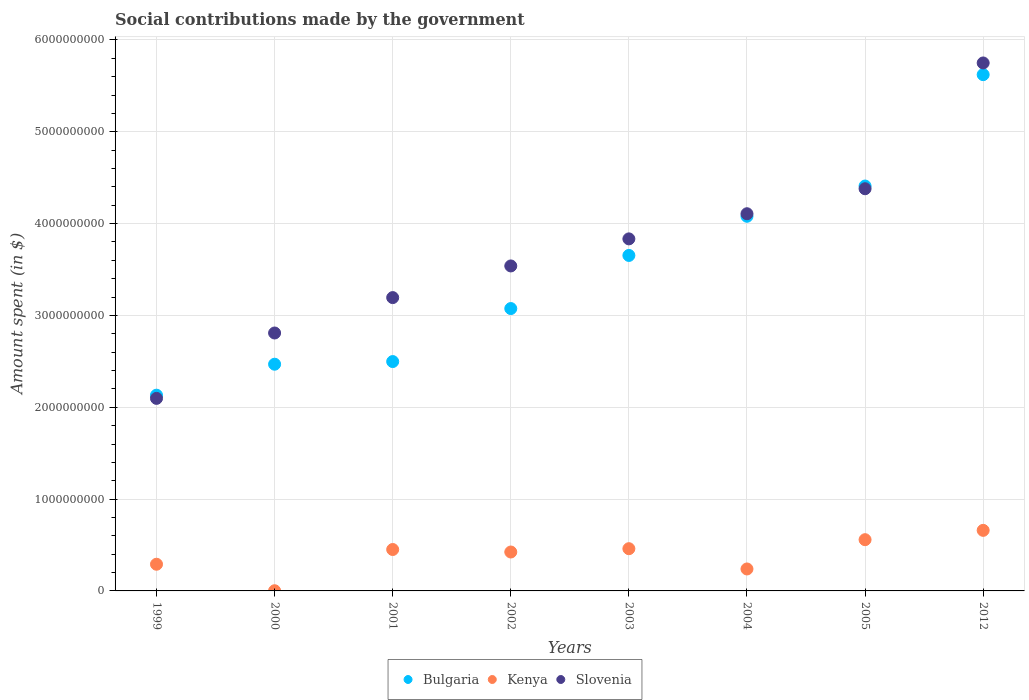How many different coloured dotlines are there?
Make the answer very short. 3. What is the amount spent on social contributions in Kenya in 2005?
Keep it short and to the point. 5.58e+08. Across all years, what is the maximum amount spent on social contributions in Kenya?
Offer a very short reply. 6.60e+08. Across all years, what is the minimum amount spent on social contributions in Bulgaria?
Ensure brevity in your answer.  2.13e+09. In which year was the amount spent on social contributions in Kenya maximum?
Provide a succinct answer. 2012. In which year was the amount spent on social contributions in Bulgaria minimum?
Keep it short and to the point. 1999. What is the total amount spent on social contributions in Kenya in the graph?
Your answer should be compact. 3.08e+09. What is the difference between the amount spent on social contributions in Slovenia in 2001 and that in 2012?
Offer a terse response. -2.56e+09. What is the difference between the amount spent on social contributions in Slovenia in 2000 and the amount spent on social contributions in Kenya in 2005?
Your answer should be very brief. 2.25e+09. What is the average amount spent on social contributions in Bulgaria per year?
Provide a short and direct response. 3.49e+09. In the year 2004, what is the difference between the amount spent on social contributions in Bulgaria and amount spent on social contributions in Slovenia?
Make the answer very short. -2.76e+07. What is the ratio of the amount spent on social contributions in Bulgaria in 2000 to that in 2005?
Your answer should be compact. 0.56. Is the amount spent on social contributions in Kenya in 1999 less than that in 2005?
Your answer should be very brief. Yes. What is the difference between the highest and the second highest amount spent on social contributions in Kenya?
Offer a terse response. 1.02e+08. What is the difference between the highest and the lowest amount spent on social contributions in Kenya?
Give a very brief answer. 6.58e+08. Is it the case that in every year, the sum of the amount spent on social contributions in Bulgaria and amount spent on social contributions in Slovenia  is greater than the amount spent on social contributions in Kenya?
Make the answer very short. Yes. Is the amount spent on social contributions in Bulgaria strictly greater than the amount spent on social contributions in Slovenia over the years?
Provide a succinct answer. No. How many dotlines are there?
Keep it short and to the point. 3. How many years are there in the graph?
Keep it short and to the point. 8. Does the graph contain grids?
Provide a succinct answer. Yes. Where does the legend appear in the graph?
Offer a terse response. Bottom center. What is the title of the graph?
Your answer should be very brief. Social contributions made by the government. Does "Middle income" appear as one of the legend labels in the graph?
Provide a short and direct response. No. What is the label or title of the X-axis?
Give a very brief answer. Years. What is the label or title of the Y-axis?
Offer a very short reply. Amount spent (in $). What is the Amount spent (in $) in Bulgaria in 1999?
Give a very brief answer. 2.13e+09. What is the Amount spent (in $) of Kenya in 1999?
Offer a very short reply. 2.91e+08. What is the Amount spent (in $) in Slovenia in 1999?
Your answer should be compact. 2.10e+09. What is the Amount spent (in $) of Bulgaria in 2000?
Your answer should be very brief. 2.47e+09. What is the Amount spent (in $) in Kenya in 2000?
Keep it short and to the point. 2.00e+06. What is the Amount spent (in $) in Slovenia in 2000?
Your answer should be very brief. 2.81e+09. What is the Amount spent (in $) in Bulgaria in 2001?
Ensure brevity in your answer.  2.50e+09. What is the Amount spent (in $) in Kenya in 2001?
Make the answer very short. 4.51e+08. What is the Amount spent (in $) in Slovenia in 2001?
Your response must be concise. 3.19e+09. What is the Amount spent (in $) of Bulgaria in 2002?
Keep it short and to the point. 3.08e+09. What is the Amount spent (in $) in Kenya in 2002?
Make the answer very short. 4.24e+08. What is the Amount spent (in $) in Slovenia in 2002?
Your answer should be very brief. 3.54e+09. What is the Amount spent (in $) in Bulgaria in 2003?
Your answer should be compact. 3.65e+09. What is the Amount spent (in $) of Kenya in 2003?
Offer a very short reply. 4.60e+08. What is the Amount spent (in $) in Slovenia in 2003?
Give a very brief answer. 3.83e+09. What is the Amount spent (in $) in Bulgaria in 2004?
Your answer should be very brief. 4.08e+09. What is the Amount spent (in $) of Kenya in 2004?
Your response must be concise. 2.39e+08. What is the Amount spent (in $) in Slovenia in 2004?
Your answer should be very brief. 4.11e+09. What is the Amount spent (in $) of Bulgaria in 2005?
Your answer should be compact. 4.41e+09. What is the Amount spent (in $) of Kenya in 2005?
Your answer should be compact. 5.58e+08. What is the Amount spent (in $) of Slovenia in 2005?
Your answer should be very brief. 4.38e+09. What is the Amount spent (in $) of Bulgaria in 2012?
Offer a terse response. 5.62e+09. What is the Amount spent (in $) in Kenya in 2012?
Keep it short and to the point. 6.60e+08. What is the Amount spent (in $) in Slovenia in 2012?
Your response must be concise. 5.75e+09. Across all years, what is the maximum Amount spent (in $) of Bulgaria?
Offer a terse response. 5.62e+09. Across all years, what is the maximum Amount spent (in $) in Kenya?
Provide a succinct answer. 6.60e+08. Across all years, what is the maximum Amount spent (in $) in Slovenia?
Keep it short and to the point. 5.75e+09. Across all years, what is the minimum Amount spent (in $) of Bulgaria?
Your answer should be compact. 2.13e+09. Across all years, what is the minimum Amount spent (in $) of Slovenia?
Provide a succinct answer. 2.10e+09. What is the total Amount spent (in $) in Bulgaria in the graph?
Offer a terse response. 2.79e+1. What is the total Amount spent (in $) in Kenya in the graph?
Ensure brevity in your answer.  3.08e+09. What is the total Amount spent (in $) of Slovenia in the graph?
Provide a succinct answer. 2.97e+1. What is the difference between the Amount spent (in $) in Bulgaria in 1999 and that in 2000?
Keep it short and to the point. -3.37e+08. What is the difference between the Amount spent (in $) in Kenya in 1999 and that in 2000?
Your response must be concise. 2.89e+08. What is the difference between the Amount spent (in $) of Slovenia in 1999 and that in 2000?
Your response must be concise. -7.12e+08. What is the difference between the Amount spent (in $) of Bulgaria in 1999 and that in 2001?
Your response must be concise. -3.66e+08. What is the difference between the Amount spent (in $) of Kenya in 1999 and that in 2001?
Provide a succinct answer. -1.60e+08. What is the difference between the Amount spent (in $) of Slovenia in 1999 and that in 2001?
Your answer should be compact. -1.10e+09. What is the difference between the Amount spent (in $) in Bulgaria in 1999 and that in 2002?
Provide a succinct answer. -9.43e+08. What is the difference between the Amount spent (in $) of Kenya in 1999 and that in 2002?
Ensure brevity in your answer.  -1.33e+08. What is the difference between the Amount spent (in $) in Slovenia in 1999 and that in 2002?
Offer a very short reply. -1.44e+09. What is the difference between the Amount spent (in $) in Bulgaria in 1999 and that in 2003?
Offer a terse response. -1.52e+09. What is the difference between the Amount spent (in $) of Kenya in 1999 and that in 2003?
Offer a very short reply. -1.69e+08. What is the difference between the Amount spent (in $) in Slovenia in 1999 and that in 2003?
Your answer should be very brief. -1.74e+09. What is the difference between the Amount spent (in $) of Bulgaria in 1999 and that in 2004?
Provide a short and direct response. -1.95e+09. What is the difference between the Amount spent (in $) in Kenya in 1999 and that in 2004?
Keep it short and to the point. 5.15e+07. What is the difference between the Amount spent (in $) in Slovenia in 1999 and that in 2004?
Offer a very short reply. -2.01e+09. What is the difference between the Amount spent (in $) in Bulgaria in 1999 and that in 2005?
Keep it short and to the point. -2.28e+09. What is the difference between the Amount spent (in $) of Kenya in 1999 and that in 2005?
Make the answer very short. -2.67e+08. What is the difference between the Amount spent (in $) in Slovenia in 1999 and that in 2005?
Keep it short and to the point. -2.28e+09. What is the difference between the Amount spent (in $) of Bulgaria in 1999 and that in 2012?
Offer a very short reply. -3.49e+09. What is the difference between the Amount spent (in $) of Kenya in 1999 and that in 2012?
Provide a short and direct response. -3.69e+08. What is the difference between the Amount spent (in $) of Slovenia in 1999 and that in 2012?
Provide a short and direct response. -3.65e+09. What is the difference between the Amount spent (in $) of Bulgaria in 2000 and that in 2001?
Your response must be concise. -2.89e+07. What is the difference between the Amount spent (in $) in Kenya in 2000 and that in 2001?
Keep it short and to the point. -4.49e+08. What is the difference between the Amount spent (in $) of Slovenia in 2000 and that in 2001?
Your answer should be very brief. -3.85e+08. What is the difference between the Amount spent (in $) of Bulgaria in 2000 and that in 2002?
Make the answer very short. -6.06e+08. What is the difference between the Amount spent (in $) of Kenya in 2000 and that in 2002?
Your response must be concise. -4.22e+08. What is the difference between the Amount spent (in $) of Slovenia in 2000 and that in 2002?
Offer a terse response. -7.30e+08. What is the difference between the Amount spent (in $) in Bulgaria in 2000 and that in 2003?
Your answer should be compact. -1.18e+09. What is the difference between the Amount spent (in $) in Kenya in 2000 and that in 2003?
Provide a succinct answer. -4.58e+08. What is the difference between the Amount spent (in $) in Slovenia in 2000 and that in 2003?
Give a very brief answer. -1.02e+09. What is the difference between the Amount spent (in $) of Bulgaria in 2000 and that in 2004?
Your answer should be compact. -1.61e+09. What is the difference between the Amount spent (in $) of Kenya in 2000 and that in 2004?
Give a very brief answer. -2.37e+08. What is the difference between the Amount spent (in $) of Slovenia in 2000 and that in 2004?
Ensure brevity in your answer.  -1.30e+09. What is the difference between the Amount spent (in $) in Bulgaria in 2000 and that in 2005?
Offer a very short reply. -1.94e+09. What is the difference between the Amount spent (in $) in Kenya in 2000 and that in 2005?
Your answer should be very brief. -5.56e+08. What is the difference between the Amount spent (in $) in Slovenia in 2000 and that in 2005?
Keep it short and to the point. -1.57e+09. What is the difference between the Amount spent (in $) in Bulgaria in 2000 and that in 2012?
Keep it short and to the point. -3.15e+09. What is the difference between the Amount spent (in $) of Kenya in 2000 and that in 2012?
Your answer should be compact. -6.58e+08. What is the difference between the Amount spent (in $) of Slovenia in 2000 and that in 2012?
Ensure brevity in your answer.  -2.94e+09. What is the difference between the Amount spent (in $) in Bulgaria in 2001 and that in 2002?
Provide a succinct answer. -5.77e+08. What is the difference between the Amount spent (in $) of Kenya in 2001 and that in 2002?
Your response must be concise. 2.73e+07. What is the difference between the Amount spent (in $) in Slovenia in 2001 and that in 2002?
Provide a succinct answer. -3.45e+08. What is the difference between the Amount spent (in $) in Bulgaria in 2001 and that in 2003?
Your response must be concise. -1.16e+09. What is the difference between the Amount spent (in $) in Kenya in 2001 and that in 2003?
Offer a very short reply. -8.90e+06. What is the difference between the Amount spent (in $) of Slovenia in 2001 and that in 2003?
Your response must be concise. -6.39e+08. What is the difference between the Amount spent (in $) of Bulgaria in 2001 and that in 2004?
Provide a succinct answer. -1.58e+09. What is the difference between the Amount spent (in $) of Kenya in 2001 and that in 2004?
Ensure brevity in your answer.  2.12e+08. What is the difference between the Amount spent (in $) in Slovenia in 2001 and that in 2004?
Your answer should be very brief. -9.13e+08. What is the difference between the Amount spent (in $) of Bulgaria in 2001 and that in 2005?
Provide a short and direct response. -1.91e+09. What is the difference between the Amount spent (in $) of Kenya in 2001 and that in 2005?
Keep it short and to the point. -1.07e+08. What is the difference between the Amount spent (in $) in Slovenia in 2001 and that in 2005?
Provide a succinct answer. -1.19e+09. What is the difference between the Amount spent (in $) in Bulgaria in 2001 and that in 2012?
Provide a short and direct response. -3.12e+09. What is the difference between the Amount spent (in $) of Kenya in 2001 and that in 2012?
Offer a terse response. -2.09e+08. What is the difference between the Amount spent (in $) of Slovenia in 2001 and that in 2012?
Offer a terse response. -2.56e+09. What is the difference between the Amount spent (in $) of Bulgaria in 2002 and that in 2003?
Give a very brief answer. -5.78e+08. What is the difference between the Amount spent (in $) in Kenya in 2002 and that in 2003?
Ensure brevity in your answer.  -3.62e+07. What is the difference between the Amount spent (in $) in Slovenia in 2002 and that in 2003?
Provide a short and direct response. -2.95e+08. What is the difference between the Amount spent (in $) in Bulgaria in 2002 and that in 2004?
Offer a very short reply. -1.01e+09. What is the difference between the Amount spent (in $) in Kenya in 2002 and that in 2004?
Your answer should be very brief. 1.85e+08. What is the difference between the Amount spent (in $) of Slovenia in 2002 and that in 2004?
Provide a short and direct response. -5.69e+08. What is the difference between the Amount spent (in $) of Bulgaria in 2002 and that in 2005?
Your response must be concise. -1.33e+09. What is the difference between the Amount spent (in $) of Kenya in 2002 and that in 2005?
Provide a succinct answer. -1.34e+08. What is the difference between the Amount spent (in $) of Slovenia in 2002 and that in 2005?
Ensure brevity in your answer.  -8.41e+08. What is the difference between the Amount spent (in $) in Bulgaria in 2002 and that in 2012?
Provide a succinct answer. -2.55e+09. What is the difference between the Amount spent (in $) of Kenya in 2002 and that in 2012?
Provide a succinct answer. -2.36e+08. What is the difference between the Amount spent (in $) in Slovenia in 2002 and that in 2012?
Offer a very short reply. -2.21e+09. What is the difference between the Amount spent (in $) in Bulgaria in 2003 and that in 2004?
Keep it short and to the point. -4.27e+08. What is the difference between the Amount spent (in $) in Kenya in 2003 and that in 2004?
Your answer should be compact. 2.21e+08. What is the difference between the Amount spent (in $) of Slovenia in 2003 and that in 2004?
Keep it short and to the point. -2.74e+08. What is the difference between the Amount spent (in $) in Bulgaria in 2003 and that in 2005?
Offer a terse response. -7.56e+08. What is the difference between the Amount spent (in $) of Kenya in 2003 and that in 2005?
Keep it short and to the point. -9.81e+07. What is the difference between the Amount spent (in $) in Slovenia in 2003 and that in 2005?
Keep it short and to the point. -5.46e+08. What is the difference between the Amount spent (in $) of Bulgaria in 2003 and that in 2012?
Ensure brevity in your answer.  -1.97e+09. What is the difference between the Amount spent (in $) of Kenya in 2003 and that in 2012?
Your answer should be very brief. -2.00e+08. What is the difference between the Amount spent (in $) of Slovenia in 2003 and that in 2012?
Offer a terse response. -1.92e+09. What is the difference between the Amount spent (in $) of Bulgaria in 2004 and that in 2005?
Give a very brief answer. -3.29e+08. What is the difference between the Amount spent (in $) in Kenya in 2004 and that in 2005?
Offer a terse response. -3.19e+08. What is the difference between the Amount spent (in $) of Slovenia in 2004 and that in 2005?
Ensure brevity in your answer.  -2.72e+08. What is the difference between the Amount spent (in $) of Bulgaria in 2004 and that in 2012?
Your answer should be very brief. -1.54e+09. What is the difference between the Amount spent (in $) in Kenya in 2004 and that in 2012?
Make the answer very short. -4.20e+08. What is the difference between the Amount spent (in $) in Slovenia in 2004 and that in 2012?
Ensure brevity in your answer.  -1.64e+09. What is the difference between the Amount spent (in $) of Bulgaria in 2005 and that in 2012?
Keep it short and to the point. -1.21e+09. What is the difference between the Amount spent (in $) of Kenya in 2005 and that in 2012?
Your answer should be compact. -1.02e+08. What is the difference between the Amount spent (in $) of Slovenia in 2005 and that in 2012?
Make the answer very short. -1.37e+09. What is the difference between the Amount spent (in $) of Bulgaria in 1999 and the Amount spent (in $) of Kenya in 2000?
Give a very brief answer. 2.13e+09. What is the difference between the Amount spent (in $) of Bulgaria in 1999 and the Amount spent (in $) of Slovenia in 2000?
Make the answer very short. -6.77e+08. What is the difference between the Amount spent (in $) in Kenya in 1999 and the Amount spent (in $) in Slovenia in 2000?
Keep it short and to the point. -2.52e+09. What is the difference between the Amount spent (in $) in Bulgaria in 1999 and the Amount spent (in $) in Kenya in 2001?
Offer a terse response. 1.68e+09. What is the difference between the Amount spent (in $) of Bulgaria in 1999 and the Amount spent (in $) of Slovenia in 2001?
Ensure brevity in your answer.  -1.06e+09. What is the difference between the Amount spent (in $) in Kenya in 1999 and the Amount spent (in $) in Slovenia in 2001?
Give a very brief answer. -2.90e+09. What is the difference between the Amount spent (in $) in Bulgaria in 1999 and the Amount spent (in $) in Kenya in 2002?
Offer a very short reply. 1.71e+09. What is the difference between the Amount spent (in $) in Bulgaria in 1999 and the Amount spent (in $) in Slovenia in 2002?
Offer a terse response. -1.41e+09. What is the difference between the Amount spent (in $) of Kenya in 1999 and the Amount spent (in $) of Slovenia in 2002?
Keep it short and to the point. -3.25e+09. What is the difference between the Amount spent (in $) of Bulgaria in 1999 and the Amount spent (in $) of Kenya in 2003?
Provide a short and direct response. 1.67e+09. What is the difference between the Amount spent (in $) in Bulgaria in 1999 and the Amount spent (in $) in Slovenia in 2003?
Ensure brevity in your answer.  -1.70e+09. What is the difference between the Amount spent (in $) in Kenya in 1999 and the Amount spent (in $) in Slovenia in 2003?
Your response must be concise. -3.54e+09. What is the difference between the Amount spent (in $) in Bulgaria in 1999 and the Amount spent (in $) in Kenya in 2004?
Make the answer very short. 1.89e+09. What is the difference between the Amount spent (in $) of Bulgaria in 1999 and the Amount spent (in $) of Slovenia in 2004?
Make the answer very short. -1.98e+09. What is the difference between the Amount spent (in $) of Kenya in 1999 and the Amount spent (in $) of Slovenia in 2004?
Keep it short and to the point. -3.82e+09. What is the difference between the Amount spent (in $) of Bulgaria in 1999 and the Amount spent (in $) of Kenya in 2005?
Your answer should be compact. 1.57e+09. What is the difference between the Amount spent (in $) in Bulgaria in 1999 and the Amount spent (in $) in Slovenia in 2005?
Your answer should be compact. -2.25e+09. What is the difference between the Amount spent (in $) of Kenya in 1999 and the Amount spent (in $) of Slovenia in 2005?
Keep it short and to the point. -4.09e+09. What is the difference between the Amount spent (in $) of Bulgaria in 1999 and the Amount spent (in $) of Kenya in 2012?
Offer a very short reply. 1.47e+09. What is the difference between the Amount spent (in $) of Bulgaria in 1999 and the Amount spent (in $) of Slovenia in 2012?
Keep it short and to the point. -3.62e+09. What is the difference between the Amount spent (in $) of Kenya in 1999 and the Amount spent (in $) of Slovenia in 2012?
Your answer should be very brief. -5.46e+09. What is the difference between the Amount spent (in $) of Bulgaria in 2000 and the Amount spent (in $) of Kenya in 2001?
Provide a short and direct response. 2.02e+09. What is the difference between the Amount spent (in $) in Bulgaria in 2000 and the Amount spent (in $) in Slovenia in 2001?
Offer a very short reply. -7.25e+08. What is the difference between the Amount spent (in $) of Kenya in 2000 and the Amount spent (in $) of Slovenia in 2001?
Make the answer very short. -3.19e+09. What is the difference between the Amount spent (in $) of Bulgaria in 2000 and the Amount spent (in $) of Kenya in 2002?
Give a very brief answer. 2.05e+09. What is the difference between the Amount spent (in $) of Bulgaria in 2000 and the Amount spent (in $) of Slovenia in 2002?
Ensure brevity in your answer.  -1.07e+09. What is the difference between the Amount spent (in $) of Kenya in 2000 and the Amount spent (in $) of Slovenia in 2002?
Keep it short and to the point. -3.54e+09. What is the difference between the Amount spent (in $) of Bulgaria in 2000 and the Amount spent (in $) of Kenya in 2003?
Provide a short and direct response. 2.01e+09. What is the difference between the Amount spent (in $) in Bulgaria in 2000 and the Amount spent (in $) in Slovenia in 2003?
Provide a succinct answer. -1.36e+09. What is the difference between the Amount spent (in $) in Kenya in 2000 and the Amount spent (in $) in Slovenia in 2003?
Your answer should be very brief. -3.83e+09. What is the difference between the Amount spent (in $) of Bulgaria in 2000 and the Amount spent (in $) of Kenya in 2004?
Offer a very short reply. 2.23e+09. What is the difference between the Amount spent (in $) of Bulgaria in 2000 and the Amount spent (in $) of Slovenia in 2004?
Give a very brief answer. -1.64e+09. What is the difference between the Amount spent (in $) in Kenya in 2000 and the Amount spent (in $) in Slovenia in 2004?
Your answer should be very brief. -4.11e+09. What is the difference between the Amount spent (in $) of Bulgaria in 2000 and the Amount spent (in $) of Kenya in 2005?
Ensure brevity in your answer.  1.91e+09. What is the difference between the Amount spent (in $) in Bulgaria in 2000 and the Amount spent (in $) in Slovenia in 2005?
Provide a short and direct response. -1.91e+09. What is the difference between the Amount spent (in $) of Kenya in 2000 and the Amount spent (in $) of Slovenia in 2005?
Keep it short and to the point. -4.38e+09. What is the difference between the Amount spent (in $) in Bulgaria in 2000 and the Amount spent (in $) in Kenya in 2012?
Give a very brief answer. 1.81e+09. What is the difference between the Amount spent (in $) in Bulgaria in 2000 and the Amount spent (in $) in Slovenia in 2012?
Your response must be concise. -3.28e+09. What is the difference between the Amount spent (in $) in Kenya in 2000 and the Amount spent (in $) in Slovenia in 2012?
Make the answer very short. -5.75e+09. What is the difference between the Amount spent (in $) in Bulgaria in 2001 and the Amount spent (in $) in Kenya in 2002?
Keep it short and to the point. 2.07e+09. What is the difference between the Amount spent (in $) in Bulgaria in 2001 and the Amount spent (in $) in Slovenia in 2002?
Provide a short and direct response. -1.04e+09. What is the difference between the Amount spent (in $) of Kenya in 2001 and the Amount spent (in $) of Slovenia in 2002?
Provide a succinct answer. -3.09e+09. What is the difference between the Amount spent (in $) of Bulgaria in 2001 and the Amount spent (in $) of Kenya in 2003?
Your answer should be compact. 2.04e+09. What is the difference between the Amount spent (in $) of Bulgaria in 2001 and the Amount spent (in $) of Slovenia in 2003?
Keep it short and to the point. -1.34e+09. What is the difference between the Amount spent (in $) of Kenya in 2001 and the Amount spent (in $) of Slovenia in 2003?
Your response must be concise. -3.38e+09. What is the difference between the Amount spent (in $) of Bulgaria in 2001 and the Amount spent (in $) of Kenya in 2004?
Ensure brevity in your answer.  2.26e+09. What is the difference between the Amount spent (in $) in Bulgaria in 2001 and the Amount spent (in $) in Slovenia in 2004?
Give a very brief answer. -1.61e+09. What is the difference between the Amount spent (in $) in Kenya in 2001 and the Amount spent (in $) in Slovenia in 2004?
Ensure brevity in your answer.  -3.66e+09. What is the difference between the Amount spent (in $) in Bulgaria in 2001 and the Amount spent (in $) in Kenya in 2005?
Your response must be concise. 1.94e+09. What is the difference between the Amount spent (in $) of Bulgaria in 2001 and the Amount spent (in $) of Slovenia in 2005?
Make the answer very short. -1.88e+09. What is the difference between the Amount spent (in $) of Kenya in 2001 and the Amount spent (in $) of Slovenia in 2005?
Offer a terse response. -3.93e+09. What is the difference between the Amount spent (in $) in Bulgaria in 2001 and the Amount spent (in $) in Kenya in 2012?
Your answer should be compact. 1.84e+09. What is the difference between the Amount spent (in $) of Bulgaria in 2001 and the Amount spent (in $) of Slovenia in 2012?
Provide a short and direct response. -3.25e+09. What is the difference between the Amount spent (in $) of Kenya in 2001 and the Amount spent (in $) of Slovenia in 2012?
Give a very brief answer. -5.30e+09. What is the difference between the Amount spent (in $) in Bulgaria in 2002 and the Amount spent (in $) in Kenya in 2003?
Offer a very short reply. 2.62e+09. What is the difference between the Amount spent (in $) in Bulgaria in 2002 and the Amount spent (in $) in Slovenia in 2003?
Ensure brevity in your answer.  -7.59e+08. What is the difference between the Amount spent (in $) in Kenya in 2002 and the Amount spent (in $) in Slovenia in 2003?
Your answer should be very brief. -3.41e+09. What is the difference between the Amount spent (in $) in Bulgaria in 2002 and the Amount spent (in $) in Kenya in 2004?
Provide a succinct answer. 2.84e+09. What is the difference between the Amount spent (in $) of Bulgaria in 2002 and the Amount spent (in $) of Slovenia in 2004?
Your answer should be very brief. -1.03e+09. What is the difference between the Amount spent (in $) in Kenya in 2002 and the Amount spent (in $) in Slovenia in 2004?
Offer a terse response. -3.68e+09. What is the difference between the Amount spent (in $) of Bulgaria in 2002 and the Amount spent (in $) of Kenya in 2005?
Offer a terse response. 2.52e+09. What is the difference between the Amount spent (in $) of Bulgaria in 2002 and the Amount spent (in $) of Slovenia in 2005?
Provide a succinct answer. -1.30e+09. What is the difference between the Amount spent (in $) of Kenya in 2002 and the Amount spent (in $) of Slovenia in 2005?
Provide a succinct answer. -3.96e+09. What is the difference between the Amount spent (in $) of Bulgaria in 2002 and the Amount spent (in $) of Kenya in 2012?
Provide a short and direct response. 2.42e+09. What is the difference between the Amount spent (in $) in Bulgaria in 2002 and the Amount spent (in $) in Slovenia in 2012?
Give a very brief answer. -2.67e+09. What is the difference between the Amount spent (in $) in Kenya in 2002 and the Amount spent (in $) in Slovenia in 2012?
Your response must be concise. -5.33e+09. What is the difference between the Amount spent (in $) in Bulgaria in 2003 and the Amount spent (in $) in Kenya in 2004?
Your answer should be very brief. 3.41e+09. What is the difference between the Amount spent (in $) in Bulgaria in 2003 and the Amount spent (in $) in Slovenia in 2004?
Provide a succinct answer. -4.54e+08. What is the difference between the Amount spent (in $) of Kenya in 2003 and the Amount spent (in $) of Slovenia in 2004?
Provide a succinct answer. -3.65e+09. What is the difference between the Amount spent (in $) of Bulgaria in 2003 and the Amount spent (in $) of Kenya in 2005?
Provide a succinct answer. 3.10e+09. What is the difference between the Amount spent (in $) of Bulgaria in 2003 and the Amount spent (in $) of Slovenia in 2005?
Your answer should be very brief. -7.26e+08. What is the difference between the Amount spent (in $) of Kenya in 2003 and the Amount spent (in $) of Slovenia in 2005?
Make the answer very short. -3.92e+09. What is the difference between the Amount spent (in $) of Bulgaria in 2003 and the Amount spent (in $) of Kenya in 2012?
Your answer should be very brief. 2.99e+09. What is the difference between the Amount spent (in $) in Bulgaria in 2003 and the Amount spent (in $) in Slovenia in 2012?
Give a very brief answer. -2.10e+09. What is the difference between the Amount spent (in $) in Kenya in 2003 and the Amount spent (in $) in Slovenia in 2012?
Keep it short and to the point. -5.29e+09. What is the difference between the Amount spent (in $) in Bulgaria in 2004 and the Amount spent (in $) in Kenya in 2005?
Offer a terse response. 3.52e+09. What is the difference between the Amount spent (in $) of Bulgaria in 2004 and the Amount spent (in $) of Slovenia in 2005?
Ensure brevity in your answer.  -3.00e+08. What is the difference between the Amount spent (in $) in Kenya in 2004 and the Amount spent (in $) in Slovenia in 2005?
Make the answer very short. -4.14e+09. What is the difference between the Amount spent (in $) of Bulgaria in 2004 and the Amount spent (in $) of Kenya in 2012?
Offer a very short reply. 3.42e+09. What is the difference between the Amount spent (in $) of Bulgaria in 2004 and the Amount spent (in $) of Slovenia in 2012?
Provide a short and direct response. -1.67e+09. What is the difference between the Amount spent (in $) of Kenya in 2004 and the Amount spent (in $) of Slovenia in 2012?
Your answer should be very brief. -5.51e+09. What is the difference between the Amount spent (in $) of Bulgaria in 2005 and the Amount spent (in $) of Kenya in 2012?
Give a very brief answer. 3.75e+09. What is the difference between the Amount spent (in $) in Bulgaria in 2005 and the Amount spent (in $) in Slovenia in 2012?
Your answer should be very brief. -1.34e+09. What is the difference between the Amount spent (in $) of Kenya in 2005 and the Amount spent (in $) of Slovenia in 2012?
Ensure brevity in your answer.  -5.19e+09. What is the average Amount spent (in $) in Bulgaria per year?
Offer a terse response. 3.49e+09. What is the average Amount spent (in $) of Kenya per year?
Provide a short and direct response. 3.85e+08. What is the average Amount spent (in $) of Slovenia per year?
Give a very brief answer. 3.71e+09. In the year 1999, what is the difference between the Amount spent (in $) of Bulgaria and Amount spent (in $) of Kenya?
Offer a very short reply. 1.84e+09. In the year 1999, what is the difference between the Amount spent (in $) in Bulgaria and Amount spent (in $) in Slovenia?
Provide a succinct answer. 3.48e+07. In the year 1999, what is the difference between the Amount spent (in $) of Kenya and Amount spent (in $) of Slovenia?
Your answer should be very brief. -1.81e+09. In the year 2000, what is the difference between the Amount spent (in $) in Bulgaria and Amount spent (in $) in Kenya?
Ensure brevity in your answer.  2.47e+09. In the year 2000, what is the difference between the Amount spent (in $) in Bulgaria and Amount spent (in $) in Slovenia?
Your response must be concise. -3.40e+08. In the year 2000, what is the difference between the Amount spent (in $) in Kenya and Amount spent (in $) in Slovenia?
Give a very brief answer. -2.81e+09. In the year 2001, what is the difference between the Amount spent (in $) of Bulgaria and Amount spent (in $) of Kenya?
Make the answer very short. 2.05e+09. In the year 2001, what is the difference between the Amount spent (in $) in Bulgaria and Amount spent (in $) in Slovenia?
Offer a terse response. -6.97e+08. In the year 2001, what is the difference between the Amount spent (in $) of Kenya and Amount spent (in $) of Slovenia?
Give a very brief answer. -2.74e+09. In the year 2002, what is the difference between the Amount spent (in $) of Bulgaria and Amount spent (in $) of Kenya?
Offer a terse response. 2.65e+09. In the year 2002, what is the difference between the Amount spent (in $) of Bulgaria and Amount spent (in $) of Slovenia?
Provide a short and direct response. -4.64e+08. In the year 2002, what is the difference between the Amount spent (in $) in Kenya and Amount spent (in $) in Slovenia?
Your answer should be compact. -3.12e+09. In the year 2003, what is the difference between the Amount spent (in $) of Bulgaria and Amount spent (in $) of Kenya?
Make the answer very short. 3.19e+09. In the year 2003, what is the difference between the Amount spent (in $) in Bulgaria and Amount spent (in $) in Slovenia?
Offer a terse response. -1.80e+08. In the year 2003, what is the difference between the Amount spent (in $) in Kenya and Amount spent (in $) in Slovenia?
Offer a very short reply. -3.37e+09. In the year 2004, what is the difference between the Amount spent (in $) of Bulgaria and Amount spent (in $) of Kenya?
Offer a terse response. 3.84e+09. In the year 2004, what is the difference between the Amount spent (in $) in Bulgaria and Amount spent (in $) in Slovenia?
Ensure brevity in your answer.  -2.76e+07. In the year 2004, what is the difference between the Amount spent (in $) of Kenya and Amount spent (in $) of Slovenia?
Keep it short and to the point. -3.87e+09. In the year 2005, what is the difference between the Amount spent (in $) of Bulgaria and Amount spent (in $) of Kenya?
Offer a terse response. 3.85e+09. In the year 2005, what is the difference between the Amount spent (in $) of Bulgaria and Amount spent (in $) of Slovenia?
Make the answer very short. 2.96e+07. In the year 2005, what is the difference between the Amount spent (in $) of Kenya and Amount spent (in $) of Slovenia?
Your response must be concise. -3.82e+09. In the year 2012, what is the difference between the Amount spent (in $) in Bulgaria and Amount spent (in $) in Kenya?
Provide a short and direct response. 4.96e+09. In the year 2012, what is the difference between the Amount spent (in $) of Bulgaria and Amount spent (in $) of Slovenia?
Provide a short and direct response. -1.27e+08. In the year 2012, what is the difference between the Amount spent (in $) of Kenya and Amount spent (in $) of Slovenia?
Your answer should be compact. -5.09e+09. What is the ratio of the Amount spent (in $) in Bulgaria in 1999 to that in 2000?
Your response must be concise. 0.86. What is the ratio of the Amount spent (in $) in Kenya in 1999 to that in 2000?
Your answer should be compact. 145.3. What is the ratio of the Amount spent (in $) of Slovenia in 1999 to that in 2000?
Your answer should be very brief. 0.75. What is the ratio of the Amount spent (in $) in Bulgaria in 1999 to that in 2001?
Give a very brief answer. 0.85. What is the ratio of the Amount spent (in $) in Kenya in 1999 to that in 2001?
Keep it short and to the point. 0.64. What is the ratio of the Amount spent (in $) of Slovenia in 1999 to that in 2001?
Offer a very short reply. 0.66. What is the ratio of the Amount spent (in $) in Bulgaria in 1999 to that in 2002?
Provide a succinct answer. 0.69. What is the ratio of the Amount spent (in $) of Kenya in 1999 to that in 2002?
Your answer should be compact. 0.69. What is the ratio of the Amount spent (in $) in Slovenia in 1999 to that in 2002?
Provide a succinct answer. 0.59. What is the ratio of the Amount spent (in $) of Bulgaria in 1999 to that in 2003?
Offer a terse response. 0.58. What is the ratio of the Amount spent (in $) in Kenya in 1999 to that in 2003?
Provide a succinct answer. 0.63. What is the ratio of the Amount spent (in $) in Slovenia in 1999 to that in 2003?
Give a very brief answer. 0.55. What is the ratio of the Amount spent (in $) in Bulgaria in 1999 to that in 2004?
Give a very brief answer. 0.52. What is the ratio of the Amount spent (in $) in Kenya in 1999 to that in 2004?
Your answer should be very brief. 1.22. What is the ratio of the Amount spent (in $) in Slovenia in 1999 to that in 2004?
Keep it short and to the point. 0.51. What is the ratio of the Amount spent (in $) of Bulgaria in 1999 to that in 2005?
Keep it short and to the point. 0.48. What is the ratio of the Amount spent (in $) of Kenya in 1999 to that in 2005?
Provide a short and direct response. 0.52. What is the ratio of the Amount spent (in $) in Slovenia in 1999 to that in 2005?
Make the answer very short. 0.48. What is the ratio of the Amount spent (in $) in Bulgaria in 1999 to that in 2012?
Give a very brief answer. 0.38. What is the ratio of the Amount spent (in $) of Kenya in 1999 to that in 2012?
Ensure brevity in your answer.  0.44. What is the ratio of the Amount spent (in $) in Slovenia in 1999 to that in 2012?
Your response must be concise. 0.36. What is the ratio of the Amount spent (in $) of Bulgaria in 2000 to that in 2001?
Your answer should be compact. 0.99. What is the ratio of the Amount spent (in $) in Kenya in 2000 to that in 2001?
Ensure brevity in your answer.  0. What is the ratio of the Amount spent (in $) of Slovenia in 2000 to that in 2001?
Ensure brevity in your answer.  0.88. What is the ratio of the Amount spent (in $) of Bulgaria in 2000 to that in 2002?
Your response must be concise. 0.8. What is the ratio of the Amount spent (in $) in Kenya in 2000 to that in 2002?
Your answer should be very brief. 0. What is the ratio of the Amount spent (in $) in Slovenia in 2000 to that in 2002?
Your response must be concise. 0.79. What is the ratio of the Amount spent (in $) in Bulgaria in 2000 to that in 2003?
Keep it short and to the point. 0.68. What is the ratio of the Amount spent (in $) in Kenya in 2000 to that in 2003?
Make the answer very short. 0. What is the ratio of the Amount spent (in $) in Slovenia in 2000 to that in 2003?
Provide a succinct answer. 0.73. What is the ratio of the Amount spent (in $) of Bulgaria in 2000 to that in 2004?
Your answer should be compact. 0.61. What is the ratio of the Amount spent (in $) in Kenya in 2000 to that in 2004?
Your answer should be very brief. 0.01. What is the ratio of the Amount spent (in $) in Slovenia in 2000 to that in 2004?
Provide a short and direct response. 0.68. What is the ratio of the Amount spent (in $) of Bulgaria in 2000 to that in 2005?
Ensure brevity in your answer.  0.56. What is the ratio of the Amount spent (in $) in Kenya in 2000 to that in 2005?
Provide a short and direct response. 0. What is the ratio of the Amount spent (in $) of Slovenia in 2000 to that in 2005?
Provide a succinct answer. 0.64. What is the ratio of the Amount spent (in $) in Bulgaria in 2000 to that in 2012?
Provide a short and direct response. 0.44. What is the ratio of the Amount spent (in $) of Kenya in 2000 to that in 2012?
Keep it short and to the point. 0. What is the ratio of the Amount spent (in $) in Slovenia in 2000 to that in 2012?
Offer a very short reply. 0.49. What is the ratio of the Amount spent (in $) of Bulgaria in 2001 to that in 2002?
Offer a terse response. 0.81. What is the ratio of the Amount spent (in $) in Kenya in 2001 to that in 2002?
Your response must be concise. 1.06. What is the ratio of the Amount spent (in $) of Slovenia in 2001 to that in 2002?
Ensure brevity in your answer.  0.9. What is the ratio of the Amount spent (in $) of Bulgaria in 2001 to that in 2003?
Offer a very short reply. 0.68. What is the ratio of the Amount spent (in $) in Kenya in 2001 to that in 2003?
Your answer should be very brief. 0.98. What is the ratio of the Amount spent (in $) of Slovenia in 2001 to that in 2003?
Your answer should be compact. 0.83. What is the ratio of the Amount spent (in $) in Bulgaria in 2001 to that in 2004?
Make the answer very short. 0.61. What is the ratio of the Amount spent (in $) in Kenya in 2001 to that in 2004?
Ensure brevity in your answer.  1.89. What is the ratio of the Amount spent (in $) of Slovenia in 2001 to that in 2004?
Ensure brevity in your answer.  0.78. What is the ratio of the Amount spent (in $) of Bulgaria in 2001 to that in 2005?
Ensure brevity in your answer.  0.57. What is the ratio of the Amount spent (in $) in Kenya in 2001 to that in 2005?
Offer a terse response. 0.81. What is the ratio of the Amount spent (in $) of Slovenia in 2001 to that in 2005?
Offer a very short reply. 0.73. What is the ratio of the Amount spent (in $) of Bulgaria in 2001 to that in 2012?
Make the answer very short. 0.44. What is the ratio of the Amount spent (in $) of Kenya in 2001 to that in 2012?
Make the answer very short. 0.68. What is the ratio of the Amount spent (in $) of Slovenia in 2001 to that in 2012?
Offer a very short reply. 0.56. What is the ratio of the Amount spent (in $) of Bulgaria in 2002 to that in 2003?
Your answer should be very brief. 0.84. What is the ratio of the Amount spent (in $) of Kenya in 2002 to that in 2003?
Provide a succinct answer. 0.92. What is the ratio of the Amount spent (in $) of Bulgaria in 2002 to that in 2004?
Your answer should be very brief. 0.75. What is the ratio of the Amount spent (in $) of Kenya in 2002 to that in 2004?
Make the answer very short. 1.77. What is the ratio of the Amount spent (in $) of Slovenia in 2002 to that in 2004?
Give a very brief answer. 0.86. What is the ratio of the Amount spent (in $) of Bulgaria in 2002 to that in 2005?
Your answer should be compact. 0.7. What is the ratio of the Amount spent (in $) in Kenya in 2002 to that in 2005?
Your answer should be very brief. 0.76. What is the ratio of the Amount spent (in $) in Slovenia in 2002 to that in 2005?
Provide a short and direct response. 0.81. What is the ratio of the Amount spent (in $) of Bulgaria in 2002 to that in 2012?
Your answer should be compact. 0.55. What is the ratio of the Amount spent (in $) in Kenya in 2002 to that in 2012?
Your answer should be compact. 0.64. What is the ratio of the Amount spent (in $) of Slovenia in 2002 to that in 2012?
Give a very brief answer. 0.62. What is the ratio of the Amount spent (in $) of Bulgaria in 2003 to that in 2004?
Your answer should be very brief. 0.9. What is the ratio of the Amount spent (in $) in Kenya in 2003 to that in 2004?
Offer a terse response. 1.92. What is the ratio of the Amount spent (in $) in Bulgaria in 2003 to that in 2005?
Make the answer very short. 0.83. What is the ratio of the Amount spent (in $) of Kenya in 2003 to that in 2005?
Ensure brevity in your answer.  0.82. What is the ratio of the Amount spent (in $) of Slovenia in 2003 to that in 2005?
Offer a terse response. 0.88. What is the ratio of the Amount spent (in $) in Bulgaria in 2003 to that in 2012?
Make the answer very short. 0.65. What is the ratio of the Amount spent (in $) in Kenya in 2003 to that in 2012?
Give a very brief answer. 0.7. What is the ratio of the Amount spent (in $) in Slovenia in 2003 to that in 2012?
Your answer should be very brief. 0.67. What is the ratio of the Amount spent (in $) of Bulgaria in 2004 to that in 2005?
Make the answer very short. 0.93. What is the ratio of the Amount spent (in $) in Kenya in 2004 to that in 2005?
Provide a succinct answer. 0.43. What is the ratio of the Amount spent (in $) of Slovenia in 2004 to that in 2005?
Ensure brevity in your answer.  0.94. What is the ratio of the Amount spent (in $) of Bulgaria in 2004 to that in 2012?
Your answer should be compact. 0.73. What is the ratio of the Amount spent (in $) of Kenya in 2004 to that in 2012?
Your answer should be compact. 0.36. What is the ratio of the Amount spent (in $) of Slovenia in 2004 to that in 2012?
Your response must be concise. 0.71. What is the ratio of the Amount spent (in $) of Bulgaria in 2005 to that in 2012?
Your answer should be compact. 0.78. What is the ratio of the Amount spent (in $) of Kenya in 2005 to that in 2012?
Your answer should be compact. 0.85. What is the ratio of the Amount spent (in $) in Slovenia in 2005 to that in 2012?
Provide a succinct answer. 0.76. What is the difference between the highest and the second highest Amount spent (in $) of Bulgaria?
Offer a very short reply. 1.21e+09. What is the difference between the highest and the second highest Amount spent (in $) in Kenya?
Provide a succinct answer. 1.02e+08. What is the difference between the highest and the second highest Amount spent (in $) of Slovenia?
Offer a terse response. 1.37e+09. What is the difference between the highest and the lowest Amount spent (in $) of Bulgaria?
Offer a terse response. 3.49e+09. What is the difference between the highest and the lowest Amount spent (in $) of Kenya?
Your response must be concise. 6.58e+08. What is the difference between the highest and the lowest Amount spent (in $) of Slovenia?
Ensure brevity in your answer.  3.65e+09. 